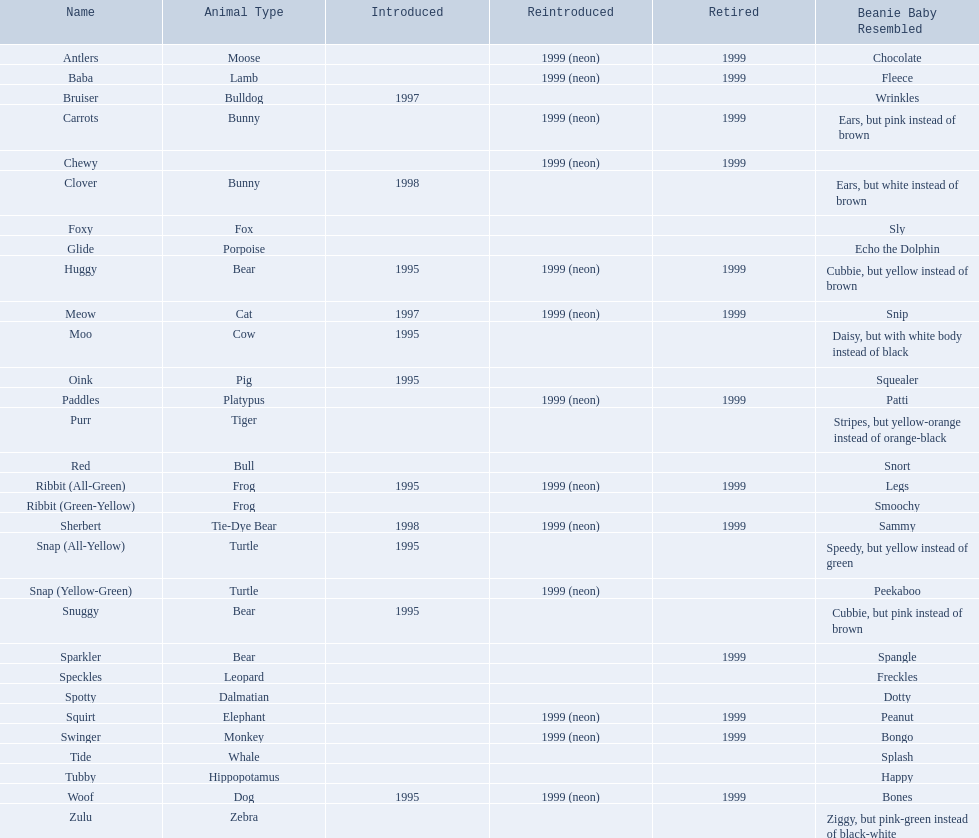What are the various sorts of pillow pal species? Antlers, Moose, Lamb, Bulldog, Bunny, , Bunny, Fox, Porpoise, Bear, Cat, Cow, Pig, Platypus, Tiger, Bull, Frog, Frog, Tie-Dye Bear, Turtle, Turtle, Bear, Bear, Leopard, Dalmatian, Elephant, Monkey, Whale, Hippopotamus, Dog, Zebra. Of these, which is a dalmatian? Dalmatian. What is the dalmatian's moniker? Spotty. 